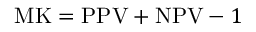<formula> <loc_0><loc_0><loc_500><loc_500>M K = P P V + N P V - 1</formula> 